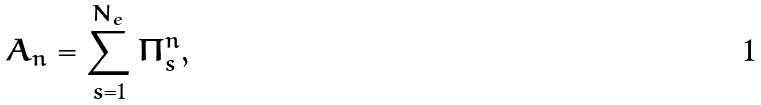Convert formula to latex. <formula><loc_0><loc_0><loc_500><loc_500>A _ { n } = \sum _ { s = 1 } ^ { N _ { e } } \Pi _ { s } ^ { n } ,</formula> 